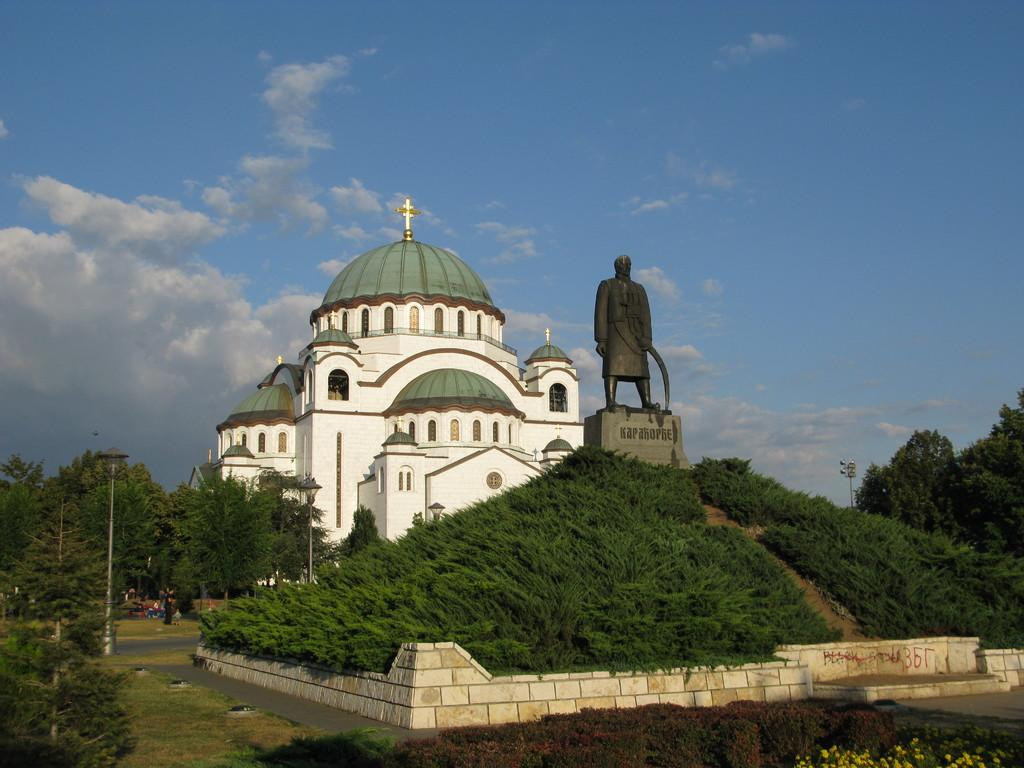What is the main structure in the middle of the image? There is a church in the middle of the image. What is located in front of the church? There is a statue in front of the church. What is visible at the top of the image? The sky is visible at the top of the image. What type of vegetation is at the bottom of the image? There are trees at the bottom of the image. What else can be seen at the bottom of the image? There are light poles at the bottom of the image. Can you tell me how many parents are visible in the image? There is no mention of parents in the provided facts, so it cannot be determined from the image. 